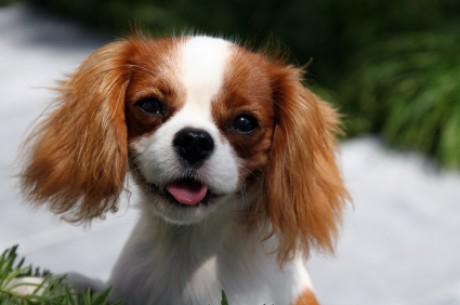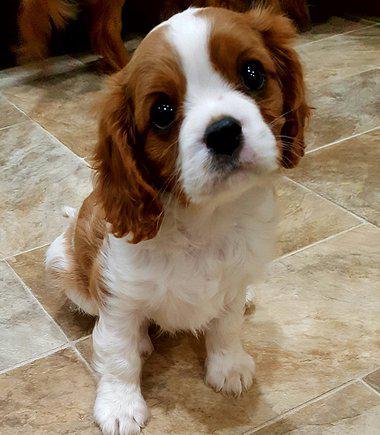The first image is the image on the left, the second image is the image on the right. Analyze the images presented: Is the assertion "There is exactly one dog with black and white fur." valid? Answer yes or no. No. The first image is the image on the left, the second image is the image on the right. Examine the images to the left and right. Is the description "Pinkish flowers are in the background behind at least one dog that is sitting upright." accurate? Answer yes or no. No. 